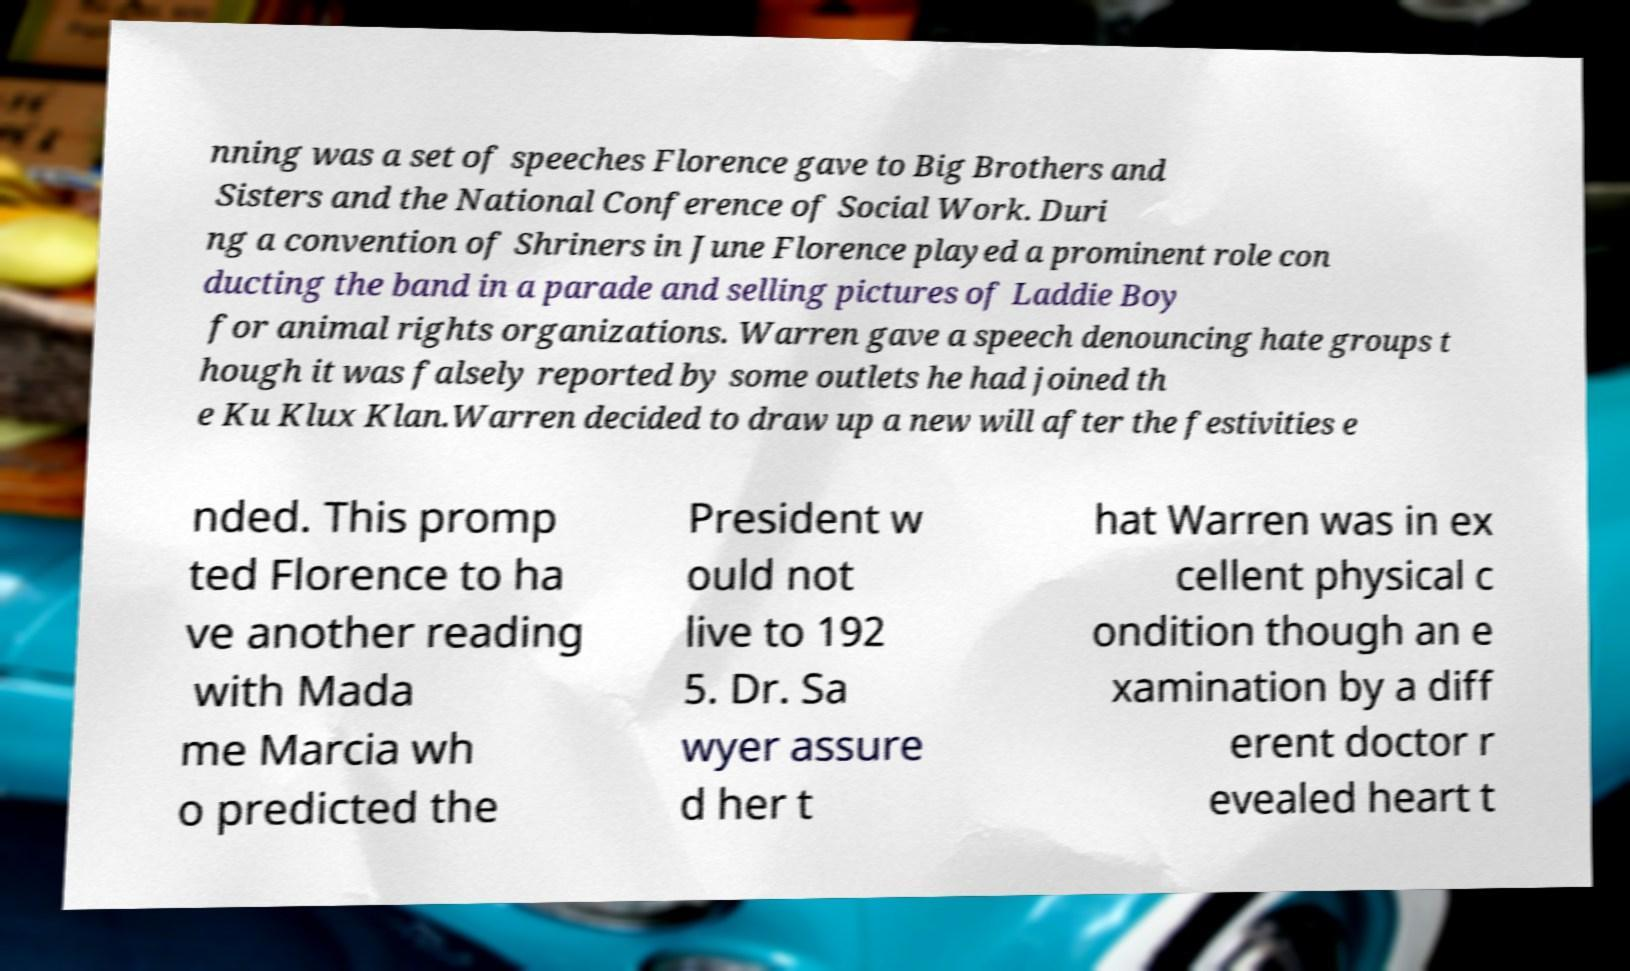Please read and relay the text visible in this image. What does it say? nning was a set of speeches Florence gave to Big Brothers and Sisters and the National Conference of Social Work. Duri ng a convention of Shriners in June Florence played a prominent role con ducting the band in a parade and selling pictures of Laddie Boy for animal rights organizations. Warren gave a speech denouncing hate groups t hough it was falsely reported by some outlets he had joined th e Ku Klux Klan.Warren decided to draw up a new will after the festivities e nded. This promp ted Florence to ha ve another reading with Mada me Marcia wh o predicted the President w ould not live to 192 5. Dr. Sa wyer assure d her t hat Warren was in ex cellent physical c ondition though an e xamination by a diff erent doctor r evealed heart t 